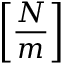Convert formula to latex. <formula><loc_0><loc_0><loc_500><loc_500>\left [ \frac { N } { m } \right ]</formula> 